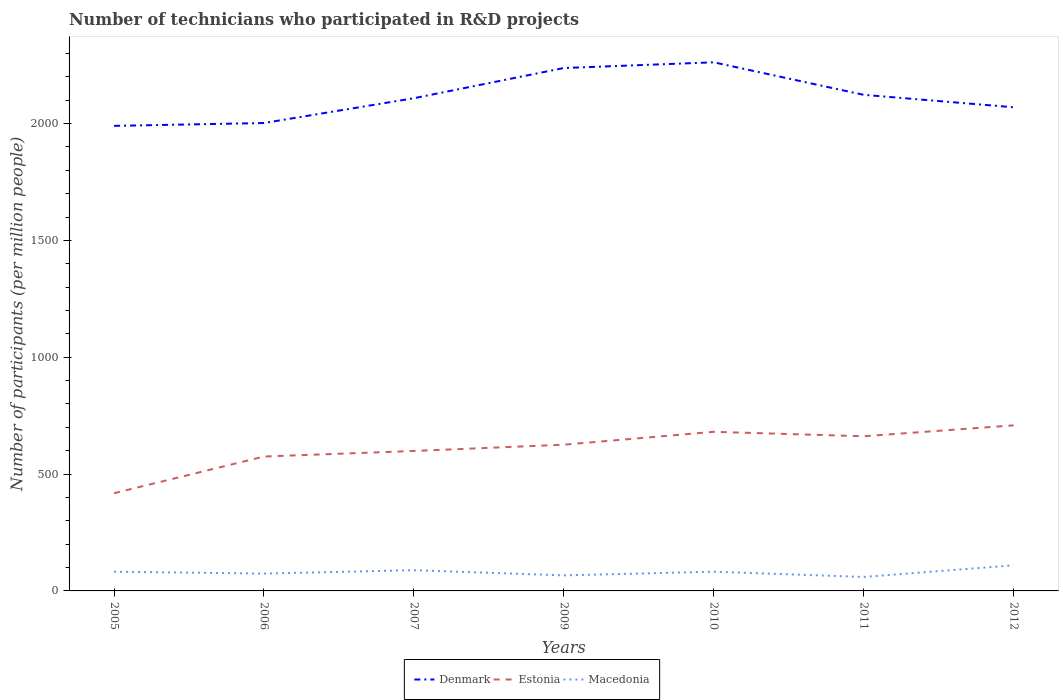Does the line corresponding to Denmark intersect with the line corresponding to Macedonia?
Your answer should be very brief. No. Is the number of lines equal to the number of legend labels?
Give a very brief answer. Yes. Across all years, what is the maximum number of technicians who participated in R&D projects in Denmark?
Provide a short and direct response. 1990.05. In which year was the number of technicians who participated in R&D projects in Denmark maximum?
Ensure brevity in your answer.  2005. What is the total number of technicians who participated in R&D projects in Macedonia in the graph?
Ensure brevity in your answer.  -20.86. What is the difference between the highest and the second highest number of technicians who participated in R&D projects in Estonia?
Provide a short and direct response. 290.19. How many years are there in the graph?
Provide a succinct answer. 7. Are the values on the major ticks of Y-axis written in scientific E-notation?
Offer a very short reply. No. Does the graph contain grids?
Ensure brevity in your answer.  No. Where does the legend appear in the graph?
Your answer should be compact. Bottom center. How many legend labels are there?
Your response must be concise. 3. How are the legend labels stacked?
Provide a short and direct response. Horizontal. What is the title of the graph?
Your response must be concise. Number of technicians who participated in R&D projects. Does "Denmark" appear as one of the legend labels in the graph?
Keep it short and to the point. Yes. What is the label or title of the Y-axis?
Provide a short and direct response. Number of participants (per million people). What is the Number of participants (per million people) in Denmark in 2005?
Give a very brief answer. 1990.05. What is the Number of participants (per million people) in Estonia in 2005?
Make the answer very short. 418.25. What is the Number of participants (per million people) in Macedonia in 2005?
Give a very brief answer. 82.24. What is the Number of participants (per million people) in Denmark in 2006?
Give a very brief answer. 2002.29. What is the Number of participants (per million people) of Estonia in 2006?
Offer a terse response. 575.08. What is the Number of participants (per million people) of Macedonia in 2006?
Provide a succinct answer. 74.24. What is the Number of participants (per million people) in Denmark in 2007?
Make the answer very short. 2108.42. What is the Number of participants (per million people) of Estonia in 2007?
Ensure brevity in your answer.  598.85. What is the Number of participants (per million people) in Macedonia in 2007?
Offer a very short reply. 88.72. What is the Number of participants (per million people) in Denmark in 2009?
Offer a very short reply. 2237.63. What is the Number of participants (per million people) in Estonia in 2009?
Provide a succinct answer. 625.74. What is the Number of participants (per million people) in Macedonia in 2009?
Make the answer very short. 66.54. What is the Number of participants (per million people) in Denmark in 2010?
Offer a terse response. 2262.1. What is the Number of participants (per million people) of Estonia in 2010?
Your answer should be very brief. 680.89. What is the Number of participants (per million people) in Macedonia in 2010?
Ensure brevity in your answer.  82.28. What is the Number of participants (per million people) in Denmark in 2011?
Provide a succinct answer. 2122.99. What is the Number of participants (per million people) of Estonia in 2011?
Make the answer very short. 661.86. What is the Number of participants (per million people) of Macedonia in 2011?
Ensure brevity in your answer.  59.77. What is the Number of participants (per million people) of Denmark in 2012?
Offer a terse response. 2069.7. What is the Number of participants (per million people) in Estonia in 2012?
Provide a short and direct response. 708.44. What is the Number of participants (per million people) in Macedonia in 2012?
Make the answer very short. 109.58. Across all years, what is the maximum Number of participants (per million people) in Denmark?
Give a very brief answer. 2262.1. Across all years, what is the maximum Number of participants (per million people) in Estonia?
Your answer should be compact. 708.44. Across all years, what is the maximum Number of participants (per million people) of Macedonia?
Your answer should be very brief. 109.58. Across all years, what is the minimum Number of participants (per million people) in Denmark?
Offer a terse response. 1990.05. Across all years, what is the minimum Number of participants (per million people) of Estonia?
Keep it short and to the point. 418.25. Across all years, what is the minimum Number of participants (per million people) of Macedonia?
Your answer should be very brief. 59.77. What is the total Number of participants (per million people) in Denmark in the graph?
Your answer should be very brief. 1.48e+04. What is the total Number of participants (per million people) of Estonia in the graph?
Offer a terse response. 4269.11. What is the total Number of participants (per million people) of Macedonia in the graph?
Make the answer very short. 563.36. What is the difference between the Number of participants (per million people) in Denmark in 2005 and that in 2006?
Provide a succinct answer. -12.24. What is the difference between the Number of participants (per million people) of Estonia in 2005 and that in 2006?
Offer a very short reply. -156.84. What is the difference between the Number of participants (per million people) in Macedonia in 2005 and that in 2006?
Keep it short and to the point. 7.99. What is the difference between the Number of participants (per million people) in Denmark in 2005 and that in 2007?
Ensure brevity in your answer.  -118.37. What is the difference between the Number of participants (per million people) of Estonia in 2005 and that in 2007?
Your answer should be compact. -180.61. What is the difference between the Number of participants (per million people) of Macedonia in 2005 and that in 2007?
Give a very brief answer. -6.48. What is the difference between the Number of participants (per million people) in Denmark in 2005 and that in 2009?
Your answer should be very brief. -247.57. What is the difference between the Number of participants (per million people) in Estonia in 2005 and that in 2009?
Your response must be concise. -207.5. What is the difference between the Number of participants (per million people) of Macedonia in 2005 and that in 2009?
Give a very brief answer. 15.7. What is the difference between the Number of participants (per million people) of Denmark in 2005 and that in 2010?
Offer a terse response. -272.04. What is the difference between the Number of participants (per million people) of Estonia in 2005 and that in 2010?
Keep it short and to the point. -262.64. What is the difference between the Number of participants (per million people) in Macedonia in 2005 and that in 2010?
Your answer should be very brief. -0.04. What is the difference between the Number of participants (per million people) of Denmark in 2005 and that in 2011?
Keep it short and to the point. -132.93. What is the difference between the Number of participants (per million people) of Estonia in 2005 and that in 2011?
Your response must be concise. -243.62. What is the difference between the Number of participants (per million people) of Macedonia in 2005 and that in 2011?
Give a very brief answer. 22.47. What is the difference between the Number of participants (per million people) in Denmark in 2005 and that in 2012?
Offer a very short reply. -79.65. What is the difference between the Number of participants (per million people) in Estonia in 2005 and that in 2012?
Give a very brief answer. -290.19. What is the difference between the Number of participants (per million people) in Macedonia in 2005 and that in 2012?
Provide a succinct answer. -27.34. What is the difference between the Number of participants (per million people) of Denmark in 2006 and that in 2007?
Your answer should be compact. -106.13. What is the difference between the Number of participants (per million people) in Estonia in 2006 and that in 2007?
Your response must be concise. -23.77. What is the difference between the Number of participants (per million people) of Macedonia in 2006 and that in 2007?
Keep it short and to the point. -14.48. What is the difference between the Number of participants (per million people) of Denmark in 2006 and that in 2009?
Provide a succinct answer. -235.33. What is the difference between the Number of participants (per million people) in Estonia in 2006 and that in 2009?
Your response must be concise. -50.66. What is the difference between the Number of participants (per million people) in Macedonia in 2006 and that in 2009?
Provide a short and direct response. 7.7. What is the difference between the Number of participants (per million people) of Denmark in 2006 and that in 2010?
Make the answer very short. -259.8. What is the difference between the Number of participants (per million people) in Estonia in 2006 and that in 2010?
Your response must be concise. -105.8. What is the difference between the Number of participants (per million people) in Macedonia in 2006 and that in 2010?
Give a very brief answer. -8.04. What is the difference between the Number of participants (per million people) of Denmark in 2006 and that in 2011?
Provide a succinct answer. -120.69. What is the difference between the Number of participants (per million people) in Estonia in 2006 and that in 2011?
Offer a terse response. -86.78. What is the difference between the Number of participants (per million people) in Macedonia in 2006 and that in 2011?
Give a very brief answer. 14.48. What is the difference between the Number of participants (per million people) in Denmark in 2006 and that in 2012?
Ensure brevity in your answer.  -67.41. What is the difference between the Number of participants (per million people) of Estonia in 2006 and that in 2012?
Provide a short and direct response. -133.35. What is the difference between the Number of participants (per million people) of Macedonia in 2006 and that in 2012?
Ensure brevity in your answer.  -35.34. What is the difference between the Number of participants (per million people) in Denmark in 2007 and that in 2009?
Make the answer very short. -129.21. What is the difference between the Number of participants (per million people) of Estonia in 2007 and that in 2009?
Give a very brief answer. -26.89. What is the difference between the Number of participants (per million people) in Macedonia in 2007 and that in 2009?
Your answer should be very brief. 22.18. What is the difference between the Number of participants (per million people) in Denmark in 2007 and that in 2010?
Keep it short and to the point. -153.68. What is the difference between the Number of participants (per million people) in Estonia in 2007 and that in 2010?
Provide a short and direct response. -82.03. What is the difference between the Number of participants (per million people) in Macedonia in 2007 and that in 2010?
Offer a very short reply. 6.44. What is the difference between the Number of participants (per million people) of Denmark in 2007 and that in 2011?
Your answer should be compact. -14.57. What is the difference between the Number of participants (per million people) in Estonia in 2007 and that in 2011?
Offer a very short reply. -63.01. What is the difference between the Number of participants (per million people) of Macedonia in 2007 and that in 2011?
Provide a succinct answer. 28.95. What is the difference between the Number of participants (per million people) in Denmark in 2007 and that in 2012?
Give a very brief answer. 38.72. What is the difference between the Number of participants (per million people) in Estonia in 2007 and that in 2012?
Provide a succinct answer. -109.58. What is the difference between the Number of participants (per million people) in Macedonia in 2007 and that in 2012?
Your response must be concise. -20.86. What is the difference between the Number of participants (per million people) of Denmark in 2009 and that in 2010?
Offer a terse response. -24.47. What is the difference between the Number of participants (per million people) of Estonia in 2009 and that in 2010?
Your answer should be very brief. -55.14. What is the difference between the Number of participants (per million people) in Macedonia in 2009 and that in 2010?
Give a very brief answer. -15.74. What is the difference between the Number of participants (per million people) in Denmark in 2009 and that in 2011?
Offer a very short reply. 114.64. What is the difference between the Number of participants (per million people) in Estonia in 2009 and that in 2011?
Your response must be concise. -36.12. What is the difference between the Number of participants (per million people) of Macedonia in 2009 and that in 2011?
Keep it short and to the point. 6.77. What is the difference between the Number of participants (per million people) of Denmark in 2009 and that in 2012?
Your answer should be very brief. 167.92. What is the difference between the Number of participants (per million people) in Estonia in 2009 and that in 2012?
Keep it short and to the point. -82.7. What is the difference between the Number of participants (per million people) of Macedonia in 2009 and that in 2012?
Offer a very short reply. -43.04. What is the difference between the Number of participants (per million people) of Denmark in 2010 and that in 2011?
Ensure brevity in your answer.  139.11. What is the difference between the Number of participants (per million people) of Estonia in 2010 and that in 2011?
Give a very brief answer. 19.02. What is the difference between the Number of participants (per million people) in Macedonia in 2010 and that in 2011?
Your answer should be very brief. 22.52. What is the difference between the Number of participants (per million people) of Denmark in 2010 and that in 2012?
Offer a terse response. 192.39. What is the difference between the Number of participants (per million people) of Estonia in 2010 and that in 2012?
Your answer should be very brief. -27.55. What is the difference between the Number of participants (per million people) of Macedonia in 2010 and that in 2012?
Your answer should be very brief. -27.3. What is the difference between the Number of participants (per million people) in Denmark in 2011 and that in 2012?
Ensure brevity in your answer.  53.28. What is the difference between the Number of participants (per million people) of Estonia in 2011 and that in 2012?
Ensure brevity in your answer.  -46.57. What is the difference between the Number of participants (per million people) of Macedonia in 2011 and that in 2012?
Your answer should be very brief. -49.81. What is the difference between the Number of participants (per million people) of Denmark in 2005 and the Number of participants (per million people) of Estonia in 2006?
Keep it short and to the point. 1414.97. What is the difference between the Number of participants (per million people) of Denmark in 2005 and the Number of participants (per million people) of Macedonia in 2006?
Keep it short and to the point. 1915.81. What is the difference between the Number of participants (per million people) in Estonia in 2005 and the Number of participants (per million people) in Macedonia in 2006?
Your answer should be very brief. 344. What is the difference between the Number of participants (per million people) of Denmark in 2005 and the Number of participants (per million people) of Estonia in 2007?
Offer a terse response. 1391.2. What is the difference between the Number of participants (per million people) in Denmark in 2005 and the Number of participants (per million people) in Macedonia in 2007?
Make the answer very short. 1901.33. What is the difference between the Number of participants (per million people) in Estonia in 2005 and the Number of participants (per million people) in Macedonia in 2007?
Your answer should be compact. 329.53. What is the difference between the Number of participants (per million people) of Denmark in 2005 and the Number of participants (per million people) of Estonia in 2009?
Your answer should be compact. 1364.31. What is the difference between the Number of participants (per million people) in Denmark in 2005 and the Number of participants (per million people) in Macedonia in 2009?
Your answer should be very brief. 1923.51. What is the difference between the Number of participants (per million people) in Estonia in 2005 and the Number of participants (per million people) in Macedonia in 2009?
Offer a very short reply. 351.71. What is the difference between the Number of participants (per million people) of Denmark in 2005 and the Number of participants (per million people) of Estonia in 2010?
Your answer should be very brief. 1309.17. What is the difference between the Number of participants (per million people) of Denmark in 2005 and the Number of participants (per million people) of Macedonia in 2010?
Make the answer very short. 1907.77. What is the difference between the Number of participants (per million people) in Estonia in 2005 and the Number of participants (per million people) in Macedonia in 2010?
Give a very brief answer. 335.96. What is the difference between the Number of participants (per million people) in Denmark in 2005 and the Number of participants (per million people) in Estonia in 2011?
Ensure brevity in your answer.  1328.19. What is the difference between the Number of participants (per million people) in Denmark in 2005 and the Number of participants (per million people) in Macedonia in 2011?
Your answer should be compact. 1930.29. What is the difference between the Number of participants (per million people) of Estonia in 2005 and the Number of participants (per million people) of Macedonia in 2011?
Offer a very short reply. 358.48. What is the difference between the Number of participants (per million people) of Denmark in 2005 and the Number of participants (per million people) of Estonia in 2012?
Make the answer very short. 1281.62. What is the difference between the Number of participants (per million people) in Denmark in 2005 and the Number of participants (per million people) in Macedonia in 2012?
Keep it short and to the point. 1880.47. What is the difference between the Number of participants (per million people) in Estonia in 2005 and the Number of participants (per million people) in Macedonia in 2012?
Offer a very short reply. 308.67. What is the difference between the Number of participants (per million people) in Denmark in 2006 and the Number of participants (per million people) in Estonia in 2007?
Give a very brief answer. 1403.44. What is the difference between the Number of participants (per million people) in Denmark in 2006 and the Number of participants (per million people) in Macedonia in 2007?
Offer a terse response. 1913.57. What is the difference between the Number of participants (per million people) of Estonia in 2006 and the Number of participants (per million people) of Macedonia in 2007?
Provide a short and direct response. 486.36. What is the difference between the Number of participants (per million people) of Denmark in 2006 and the Number of participants (per million people) of Estonia in 2009?
Provide a short and direct response. 1376.55. What is the difference between the Number of participants (per million people) in Denmark in 2006 and the Number of participants (per million people) in Macedonia in 2009?
Keep it short and to the point. 1935.75. What is the difference between the Number of participants (per million people) of Estonia in 2006 and the Number of participants (per million people) of Macedonia in 2009?
Ensure brevity in your answer.  508.54. What is the difference between the Number of participants (per million people) of Denmark in 2006 and the Number of participants (per million people) of Estonia in 2010?
Offer a very short reply. 1321.41. What is the difference between the Number of participants (per million people) in Denmark in 2006 and the Number of participants (per million people) in Macedonia in 2010?
Ensure brevity in your answer.  1920.01. What is the difference between the Number of participants (per million people) in Estonia in 2006 and the Number of participants (per million people) in Macedonia in 2010?
Your answer should be very brief. 492.8. What is the difference between the Number of participants (per million people) of Denmark in 2006 and the Number of participants (per million people) of Estonia in 2011?
Offer a terse response. 1340.43. What is the difference between the Number of participants (per million people) of Denmark in 2006 and the Number of participants (per million people) of Macedonia in 2011?
Make the answer very short. 1942.53. What is the difference between the Number of participants (per million people) of Estonia in 2006 and the Number of participants (per million people) of Macedonia in 2011?
Offer a terse response. 515.32. What is the difference between the Number of participants (per million people) in Denmark in 2006 and the Number of participants (per million people) in Estonia in 2012?
Make the answer very short. 1293.85. What is the difference between the Number of participants (per million people) in Denmark in 2006 and the Number of participants (per million people) in Macedonia in 2012?
Make the answer very short. 1892.71. What is the difference between the Number of participants (per million people) of Estonia in 2006 and the Number of participants (per million people) of Macedonia in 2012?
Keep it short and to the point. 465.5. What is the difference between the Number of participants (per million people) of Denmark in 2007 and the Number of participants (per million people) of Estonia in 2009?
Make the answer very short. 1482.68. What is the difference between the Number of participants (per million people) of Denmark in 2007 and the Number of participants (per million people) of Macedonia in 2009?
Make the answer very short. 2041.88. What is the difference between the Number of participants (per million people) of Estonia in 2007 and the Number of participants (per million people) of Macedonia in 2009?
Offer a very short reply. 532.31. What is the difference between the Number of participants (per million people) of Denmark in 2007 and the Number of participants (per million people) of Estonia in 2010?
Give a very brief answer. 1427.54. What is the difference between the Number of participants (per million people) of Denmark in 2007 and the Number of participants (per million people) of Macedonia in 2010?
Your answer should be compact. 2026.14. What is the difference between the Number of participants (per million people) of Estonia in 2007 and the Number of participants (per million people) of Macedonia in 2010?
Provide a succinct answer. 516.57. What is the difference between the Number of participants (per million people) in Denmark in 2007 and the Number of participants (per million people) in Estonia in 2011?
Provide a succinct answer. 1446.56. What is the difference between the Number of participants (per million people) of Denmark in 2007 and the Number of participants (per million people) of Macedonia in 2011?
Offer a very short reply. 2048.65. What is the difference between the Number of participants (per million people) in Estonia in 2007 and the Number of participants (per million people) in Macedonia in 2011?
Make the answer very short. 539.09. What is the difference between the Number of participants (per million people) in Denmark in 2007 and the Number of participants (per million people) in Estonia in 2012?
Your response must be concise. 1399.98. What is the difference between the Number of participants (per million people) of Denmark in 2007 and the Number of participants (per million people) of Macedonia in 2012?
Keep it short and to the point. 1998.84. What is the difference between the Number of participants (per million people) of Estonia in 2007 and the Number of participants (per million people) of Macedonia in 2012?
Provide a short and direct response. 489.27. What is the difference between the Number of participants (per million people) in Denmark in 2009 and the Number of participants (per million people) in Estonia in 2010?
Your response must be concise. 1556.74. What is the difference between the Number of participants (per million people) of Denmark in 2009 and the Number of participants (per million people) of Macedonia in 2010?
Keep it short and to the point. 2155.35. What is the difference between the Number of participants (per million people) of Estonia in 2009 and the Number of participants (per million people) of Macedonia in 2010?
Provide a succinct answer. 543.46. What is the difference between the Number of participants (per million people) in Denmark in 2009 and the Number of participants (per million people) in Estonia in 2011?
Your response must be concise. 1575.76. What is the difference between the Number of participants (per million people) in Denmark in 2009 and the Number of participants (per million people) in Macedonia in 2011?
Provide a succinct answer. 2177.86. What is the difference between the Number of participants (per million people) in Estonia in 2009 and the Number of participants (per million people) in Macedonia in 2011?
Keep it short and to the point. 565.98. What is the difference between the Number of participants (per million people) in Denmark in 2009 and the Number of participants (per million people) in Estonia in 2012?
Your response must be concise. 1529.19. What is the difference between the Number of participants (per million people) in Denmark in 2009 and the Number of participants (per million people) in Macedonia in 2012?
Provide a succinct answer. 2128.05. What is the difference between the Number of participants (per million people) in Estonia in 2009 and the Number of participants (per million people) in Macedonia in 2012?
Offer a terse response. 516.16. What is the difference between the Number of participants (per million people) of Denmark in 2010 and the Number of participants (per million people) of Estonia in 2011?
Your answer should be very brief. 1600.23. What is the difference between the Number of participants (per million people) in Denmark in 2010 and the Number of participants (per million people) in Macedonia in 2011?
Your response must be concise. 2202.33. What is the difference between the Number of participants (per million people) in Estonia in 2010 and the Number of participants (per million people) in Macedonia in 2011?
Provide a short and direct response. 621.12. What is the difference between the Number of participants (per million people) in Denmark in 2010 and the Number of participants (per million people) in Estonia in 2012?
Make the answer very short. 1553.66. What is the difference between the Number of participants (per million people) of Denmark in 2010 and the Number of participants (per million people) of Macedonia in 2012?
Offer a terse response. 2152.52. What is the difference between the Number of participants (per million people) of Estonia in 2010 and the Number of participants (per million people) of Macedonia in 2012?
Give a very brief answer. 571.31. What is the difference between the Number of participants (per million people) of Denmark in 2011 and the Number of participants (per million people) of Estonia in 2012?
Your answer should be compact. 1414.55. What is the difference between the Number of participants (per million people) in Denmark in 2011 and the Number of participants (per million people) in Macedonia in 2012?
Provide a short and direct response. 2013.41. What is the difference between the Number of participants (per million people) of Estonia in 2011 and the Number of participants (per million people) of Macedonia in 2012?
Make the answer very short. 552.28. What is the average Number of participants (per million people) in Denmark per year?
Provide a succinct answer. 2113.31. What is the average Number of participants (per million people) in Estonia per year?
Provide a short and direct response. 609.87. What is the average Number of participants (per million people) of Macedonia per year?
Offer a terse response. 80.48. In the year 2005, what is the difference between the Number of participants (per million people) in Denmark and Number of participants (per million people) in Estonia?
Your answer should be compact. 1571.81. In the year 2005, what is the difference between the Number of participants (per million people) of Denmark and Number of participants (per million people) of Macedonia?
Provide a succinct answer. 1907.82. In the year 2005, what is the difference between the Number of participants (per million people) of Estonia and Number of participants (per million people) of Macedonia?
Provide a short and direct response. 336.01. In the year 2006, what is the difference between the Number of participants (per million people) of Denmark and Number of participants (per million people) of Estonia?
Your response must be concise. 1427.21. In the year 2006, what is the difference between the Number of participants (per million people) of Denmark and Number of participants (per million people) of Macedonia?
Offer a terse response. 1928.05. In the year 2006, what is the difference between the Number of participants (per million people) of Estonia and Number of participants (per million people) of Macedonia?
Offer a terse response. 500.84. In the year 2007, what is the difference between the Number of participants (per million people) of Denmark and Number of participants (per million people) of Estonia?
Your answer should be very brief. 1509.57. In the year 2007, what is the difference between the Number of participants (per million people) of Denmark and Number of participants (per million people) of Macedonia?
Provide a short and direct response. 2019.7. In the year 2007, what is the difference between the Number of participants (per million people) of Estonia and Number of participants (per million people) of Macedonia?
Keep it short and to the point. 510.14. In the year 2009, what is the difference between the Number of participants (per million people) in Denmark and Number of participants (per million people) in Estonia?
Keep it short and to the point. 1611.88. In the year 2009, what is the difference between the Number of participants (per million people) in Denmark and Number of participants (per million people) in Macedonia?
Offer a very short reply. 2171.09. In the year 2009, what is the difference between the Number of participants (per million people) of Estonia and Number of participants (per million people) of Macedonia?
Your answer should be compact. 559.2. In the year 2010, what is the difference between the Number of participants (per million people) of Denmark and Number of participants (per million people) of Estonia?
Your response must be concise. 1581.21. In the year 2010, what is the difference between the Number of participants (per million people) of Denmark and Number of participants (per million people) of Macedonia?
Your answer should be compact. 2179.81. In the year 2010, what is the difference between the Number of participants (per million people) of Estonia and Number of participants (per million people) of Macedonia?
Provide a succinct answer. 598.6. In the year 2011, what is the difference between the Number of participants (per million people) in Denmark and Number of participants (per million people) in Estonia?
Offer a very short reply. 1461.12. In the year 2011, what is the difference between the Number of participants (per million people) of Denmark and Number of participants (per million people) of Macedonia?
Make the answer very short. 2063.22. In the year 2011, what is the difference between the Number of participants (per million people) of Estonia and Number of participants (per million people) of Macedonia?
Your answer should be very brief. 602.1. In the year 2012, what is the difference between the Number of participants (per million people) in Denmark and Number of participants (per million people) in Estonia?
Provide a short and direct response. 1361.27. In the year 2012, what is the difference between the Number of participants (per million people) of Denmark and Number of participants (per million people) of Macedonia?
Offer a terse response. 1960.12. In the year 2012, what is the difference between the Number of participants (per million people) in Estonia and Number of participants (per million people) in Macedonia?
Your response must be concise. 598.86. What is the ratio of the Number of participants (per million people) of Estonia in 2005 to that in 2006?
Your answer should be very brief. 0.73. What is the ratio of the Number of participants (per million people) in Macedonia in 2005 to that in 2006?
Provide a succinct answer. 1.11. What is the ratio of the Number of participants (per million people) of Denmark in 2005 to that in 2007?
Provide a succinct answer. 0.94. What is the ratio of the Number of participants (per million people) of Estonia in 2005 to that in 2007?
Your response must be concise. 0.7. What is the ratio of the Number of participants (per million people) of Macedonia in 2005 to that in 2007?
Provide a short and direct response. 0.93. What is the ratio of the Number of participants (per million people) of Denmark in 2005 to that in 2009?
Keep it short and to the point. 0.89. What is the ratio of the Number of participants (per million people) in Estonia in 2005 to that in 2009?
Provide a succinct answer. 0.67. What is the ratio of the Number of participants (per million people) of Macedonia in 2005 to that in 2009?
Your answer should be very brief. 1.24. What is the ratio of the Number of participants (per million people) in Denmark in 2005 to that in 2010?
Ensure brevity in your answer.  0.88. What is the ratio of the Number of participants (per million people) of Estonia in 2005 to that in 2010?
Provide a succinct answer. 0.61. What is the ratio of the Number of participants (per million people) in Denmark in 2005 to that in 2011?
Give a very brief answer. 0.94. What is the ratio of the Number of participants (per million people) of Estonia in 2005 to that in 2011?
Your response must be concise. 0.63. What is the ratio of the Number of participants (per million people) in Macedonia in 2005 to that in 2011?
Your response must be concise. 1.38. What is the ratio of the Number of participants (per million people) of Denmark in 2005 to that in 2012?
Your answer should be very brief. 0.96. What is the ratio of the Number of participants (per million people) of Estonia in 2005 to that in 2012?
Offer a very short reply. 0.59. What is the ratio of the Number of participants (per million people) in Macedonia in 2005 to that in 2012?
Keep it short and to the point. 0.75. What is the ratio of the Number of participants (per million people) of Denmark in 2006 to that in 2007?
Offer a very short reply. 0.95. What is the ratio of the Number of participants (per million people) in Estonia in 2006 to that in 2007?
Your answer should be very brief. 0.96. What is the ratio of the Number of participants (per million people) of Macedonia in 2006 to that in 2007?
Your response must be concise. 0.84. What is the ratio of the Number of participants (per million people) of Denmark in 2006 to that in 2009?
Offer a very short reply. 0.89. What is the ratio of the Number of participants (per million people) of Estonia in 2006 to that in 2009?
Your answer should be very brief. 0.92. What is the ratio of the Number of participants (per million people) in Macedonia in 2006 to that in 2009?
Ensure brevity in your answer.  1.12. What is the ratio of the Number of participants (per million people) in Denmark in 2006 to that in 2010?
Ensure brevity in your answer.  0.89. What is the ratio of the Number of participants (per million people) of Estonia in 2006 to that in 2010?
Your answer should be very brief. 0.84. What is the ratio of the Number of participants (per million people) of Macedonia in 2006 to that in 2010?
Offer a very short reply. 0.9. What is the ratio of the Number of participants (per million people) in Denmark in 2006 to that in 2011?
Provide a succinct answer. 0.94. What is the ratio of the Number of participants (per million people) of Estonia in 2006 to that in 2011?
Your answer should be very brief. 0.87. What is the ratio of the Number of participants (per million people) of Macedonia in 2006 to that in 2011?
Give a very brief answer. 1.24. What is the ratio of the Number of participants (per million people) in Denmark in 2006 to that in 2012?
Offer a terse response. 0.97. What is the ratio of the Number of participants (per million people) of Estonia in 2006 to that in 2012?
Offer a very short reply. 0.81. What is the ratio of the Number of participants (per million people) of Macedonia in 2006 to that in 2012?
Give a very brief answer. 0.68. What is the ratio of the Number of participants (per million people) of Denmark in 2007 to that in 2009?
Your answer should be compact. 0.94. What is the ratio of the Number of participants (per million people) of Estonia in 2007 to that in 2009?
Your answer should be very brief. 0.96. What is the ratio of the Number of participants (per million people) of Macedonia in 2007 to that in 2009?
Make the answer very short. 1.33. What is the ratio of the Number of participants (per million people) of Denmark in 2007 to that in 2010?
Provide a succinct answer. 0.93. What is the ratio of the Number of participants (per million people) of Estonia in 2007 to that in 2010?
Make the answer very short. 0.88. What is the ratio of the Number of participants (per million people) in Macedonia in 2007 to that in 2010?
Offer a terse response. 1.08. What is the ratio of the Number of participants (per million people) in Estonia in 2007 to that in 2011?
Keep it short and to the point. 0.9. What is the ratio of the Number of participants (per million people) of Macedonia in 2007 to that in 2011?
Make the answer very short. 1.48. What is the ratio of the Number of participants (per million people) of Denmark in 2007 to that in 2012?
Make the answer very short. 1.02. What is the ratio of the Number of participants (per million people) of Estonia in 2007 to that in 2012?
Offer a terse response. 0.85. What is the ratio of the Number of participants (per million people) in Macedonia in 2007 to that in 2012?
Keep it short and to the point. 0.81. What is the ratio of the Number of participants (per million people) in Denmark in 2009 to that in 2010?
Your answer should be very brief. 0.99. What is the ratio of the Number of participants (per million people) in Estonia in 2009 to that in 2010?
Make the answer very short. 0.92. What is the ratio of the Number of participants (per million people) of Macedonia in 2009 to that in 2010?
Provide a short and direct response. 0.81. What is the ratio of the Number of participants (per million people) of Denmark in 2009 to that in 2011?
Give a very brief answer. 1.05. What is the ratio of the Number of participants (per million people) of Estonia in 2009 to that in 2011?
Your response must be concise. 0.95. What is the ratio of the Number of participants (per million people) in Macedonia in 2009 to that in 2011?
Provide a succinct answer. 1.11. What is the ratio of the Number of participants (per million people) in Denmark in 2009 to that in 2012?
Your answer should be compact. 1.08. What is the ratio of the Number of participants (per million people) in Estonia in 2009 to that in 2012?
Ensure brevity in your answer.  0.88. What is the ratio of the Number of participants (per million people) of Macedonia in 2009 to that in 2012?
Provide a short and direct response. 0.61. What is the ratio of the Number of participants (per million people) in Denmark in 2010 to that in 2011?
Give a very brief answer. 1.07. What is the ratio of the Number of participants (per million people) of Estonia in 2010 to that in 2011?
Provide a short and direct response. 1.03. What is the ratio of the Number of participants (per million people) in Macedonia in 2010 to that in 2011?
Make the answer very short. 1.38. What is the ratio of the Number of participants (per million people) in Denmark in 2010 to that in 2012?
Make the answer very short. 1.09. What is the ratio of the Number of participants (per million people) of Estonia in 2010 to that in 2012?
Ensure brevity in your answer.  0.96. What is the ratio of the Number of participants (per million people) of Macedonia in 2010 to that in 2012?
Your answer should be very brief. 0.75. What is the ratio of the Number of participants (per million people) in Denmark in 2011 to that in 2012?
Your response must be concise. 1.03. What is the ratio of the Number of participants (per million people) of Estonia in 2011 to that in 2012?
Your answer should be compact. 0.93. What is the ratio of the Number of participants (per million people) of Macedonia in 2011 to that in 2012?
Your answer should be compact. 0.55. What is the difference between the highest and the second highest Number of participants (per million people) in Denmark?
Make the answer very short. 24.47. What is the difference between the highest and the second highest Number of participants (per million people) in Estonia?
Provide a succinct answer. 27.55. What is the difference between the highest and the second highest Number of participants (per million people) in Macedonia?
Your response must be concise. 20.86. What is the difference between the highest and the lowest Number of participants (per million people) of Denmark?
Give a very brief answer. 272.04. What is the difference between the highest and the lowest Number of participants (per million people) of Estonia?
Provide a short and direct response. 290.19. What is the difference between the highest and the lowest Number of participants (per million people) of Macedonia?
Your response must be concise. 49.81. 